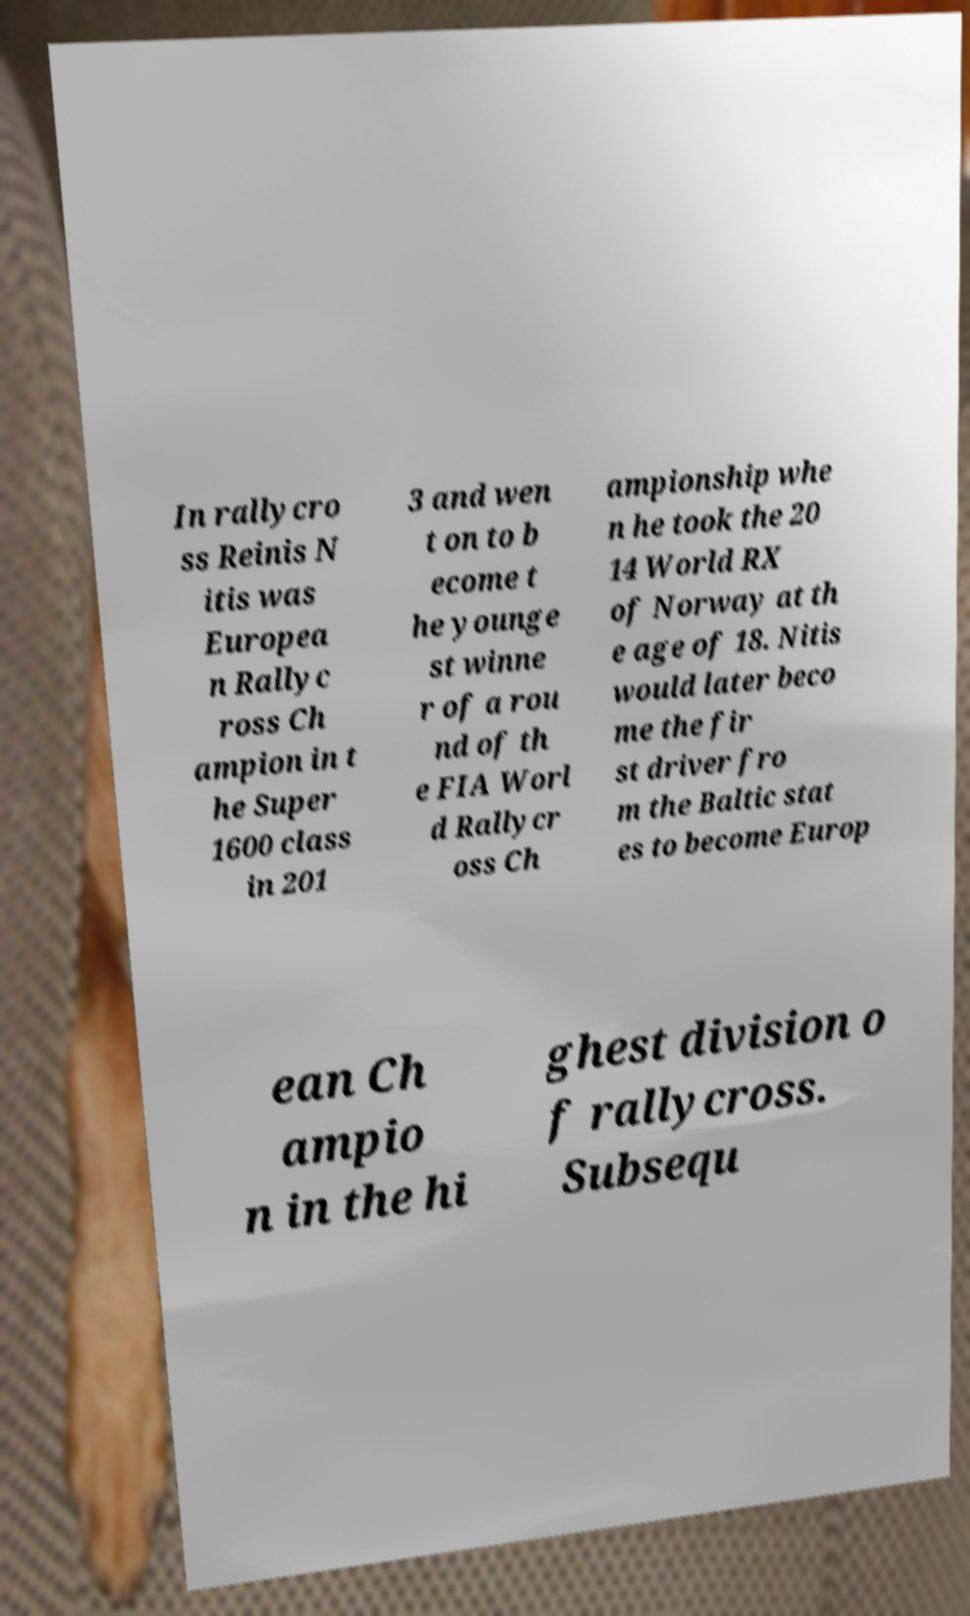For documentation purposes, I need the text within this image transcribed. Could you provide that? In rallycro ss Reinis N itis was Europea n Rallyc ross Ch ampion in t he Super 1600 class in 201 3 and wen t on to b ecome t he younge st winne r of a rou nd of th e FIA Worl d Rallycr oss Ch ampionship whe n he took the 20 14 World RX of Norway at th e age of 18. Nitis would later beco me the fir st driver fro m the Baltic stat es to become Europ ean Ch ampio n in the hi ghest division o f rallycross. Subsequ 